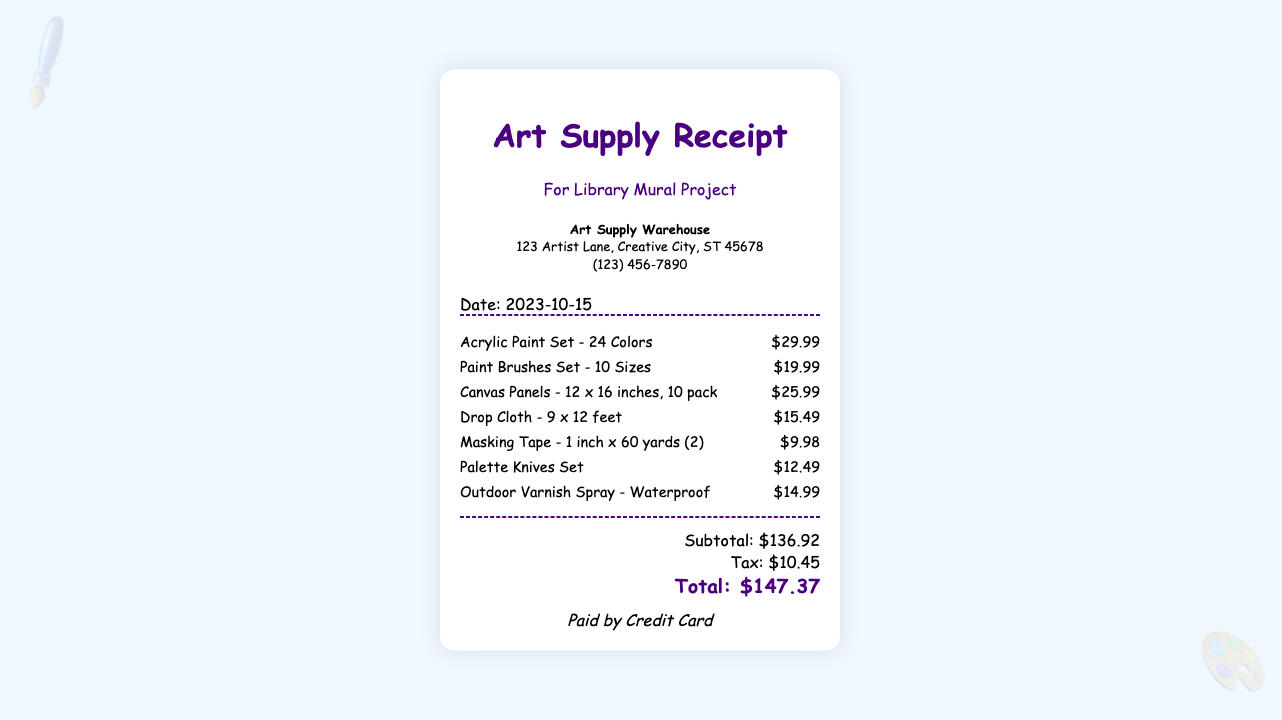What is the name of the vendor? The vendor's name is listed in the vendor info section of the receipt as "Art Supply Warehouse."
Answer: Art Supply Warehouse What is the date of the purchase? The purchase date is clearly indicated in the receipt, which states "Date: 2023-10-15."
Answer: 2023-10-15 How much did the acrylic paint set cost? The cost of the acrylic paint set is shown next to its description as "$29.99."
Answer: $29.99 What is the subtotal of the items before tax? The subtotal is presented in the totals section as "Subtotal: $136.92."
Answer: $136.92 How much was paid for tax? The receipt includes a line for tax amount, indicating "Tax: $10.45."
Answer: $10.45 What was the total amount of the receipt? The total amount concludes the totals section with "Total: $147.37."
Answer: $147.37 How many colors are in the acrylic paint set? The description of the acrylic paint set states it contains "24 Colors."
Answer: 24 Colors What type of payment was used? The payment method is specified at the end of the receipt as "Paid by Credit Card."
Answer: Credit Card How many paint brushes are included in the set? The description of the paint brushes set mentions "10 Sizes," indicating the variety available.
Answer: 10 Sizes 